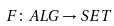Convert formula to latex. <formula><loc_0><loc_0><loc_500><loc_500>F \colon A L G \to S E T</formula> 